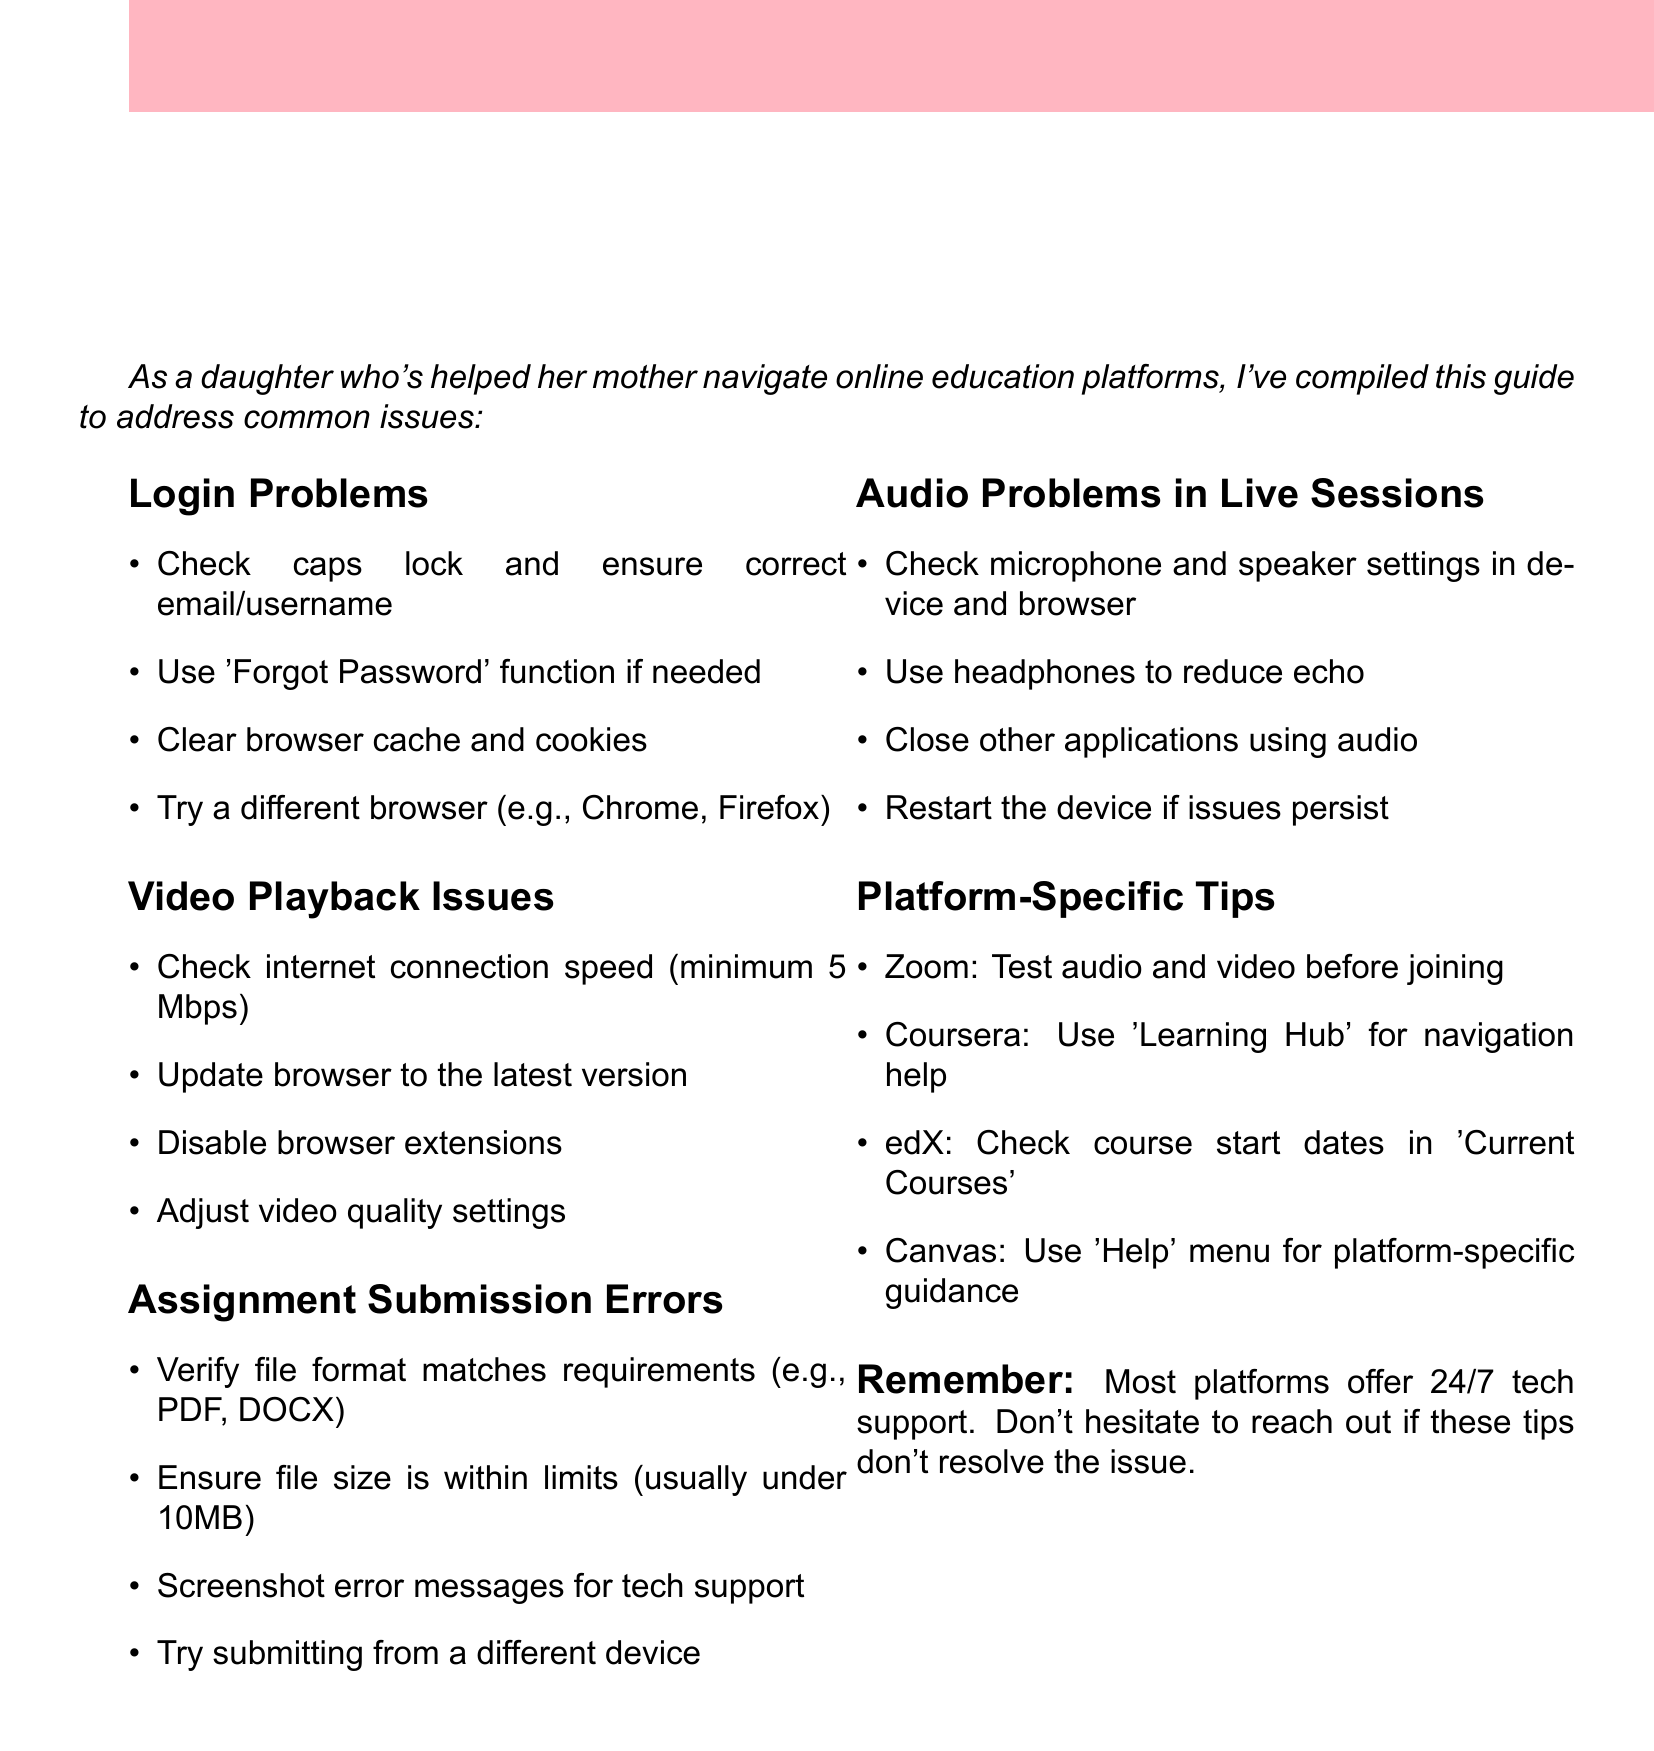what is the title of the document? The title is provided at the beginning of the document.
Answer: Quick Troubleshooting Guide for Common Online Learning Platform Issues how many sections are in the guide? The number of sections can be counted from the document's content.
Answer: Five what is the minimum internet connection speed recommended for video playback? The document specifies a minimum speed for video playback.
Answer: 5 Mbps which platform should you use the 'Learning Hub' for navigation help? The platform is mentioned specifically in the tips section of the document.
Answer: Coursera what should you do if you face assignment submission errors regarding file size? The document includes specific actions to take for submission errors.
Answer: Ensure file size is within limits (usually under 10MB) what is the best way to reduce echo in audio during live sessions? The guide provides tips for solving audio problems.
Answer: Use headphones what action should you take if you encounter login problems? The document lists troubleshooting steps for login issues.
Answer: Use 'Forgot Password' function if needed which platform advice suggests checking course start dates? The document includes platform-specific tips for various platforms.
Answer: edX 